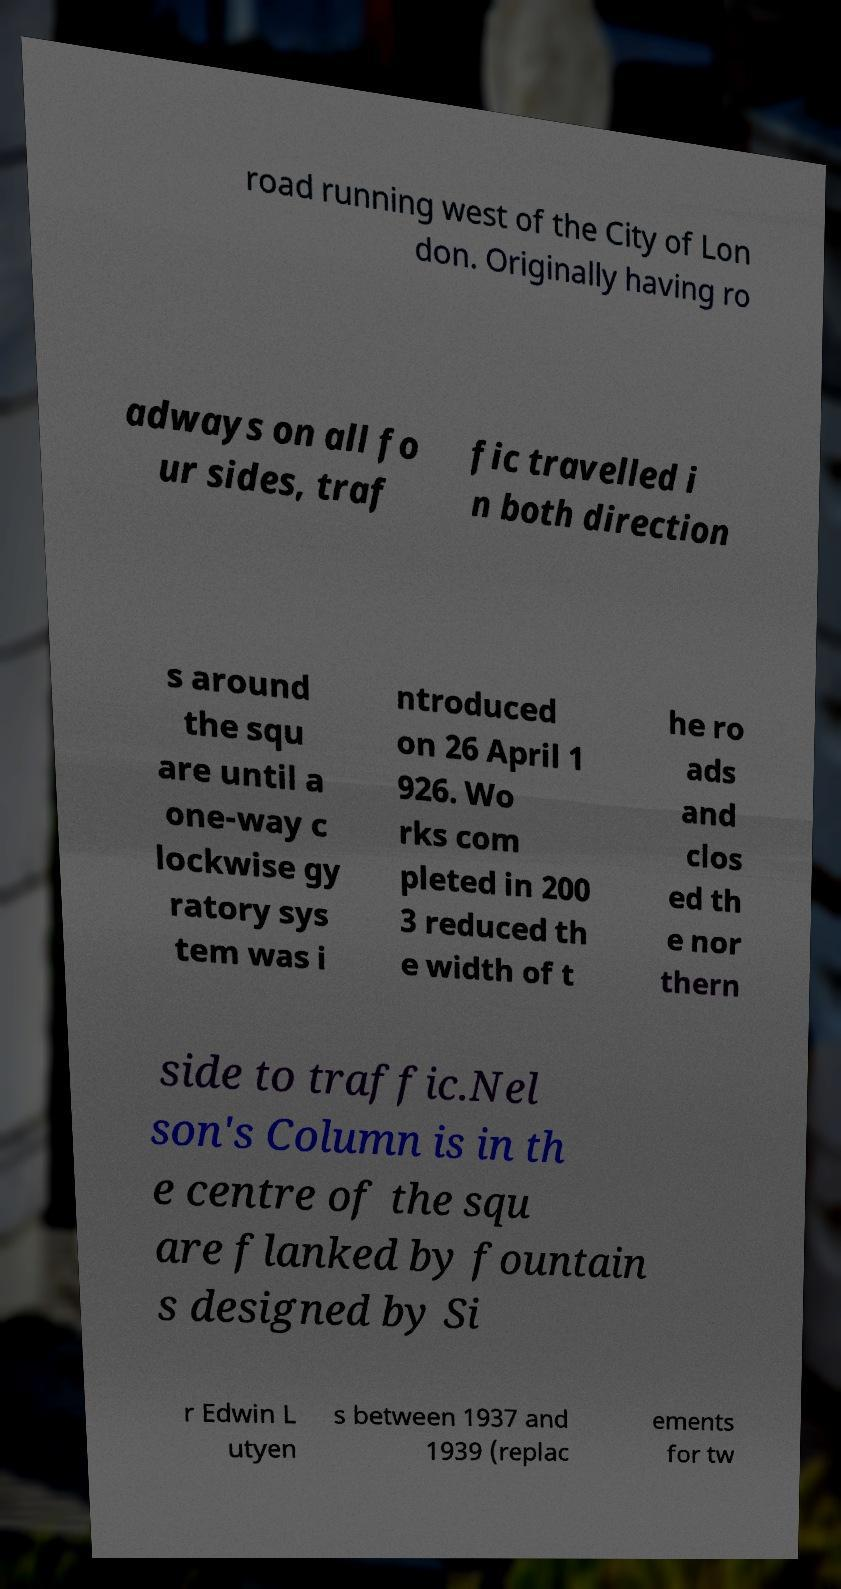Please identify and transcribe the text found in this image. road running west of the City of Lon don. Originally having ro adways on all fo ur sides, traf fic travelled i n both direction s around the squ are until a one-way c lockwise gy ratory sys tem was i ntroduced on 26 April 1 926. Wo rks com pleted in 200 3 reduced th e width of t he ro ads and clos ed th e nor thern side to traffic.Nel son's Column is in th e centre of the squ are flanked by fountain s designed by Si r Edwin L utyen s between 1937 and 1939 (replac ements for tw 